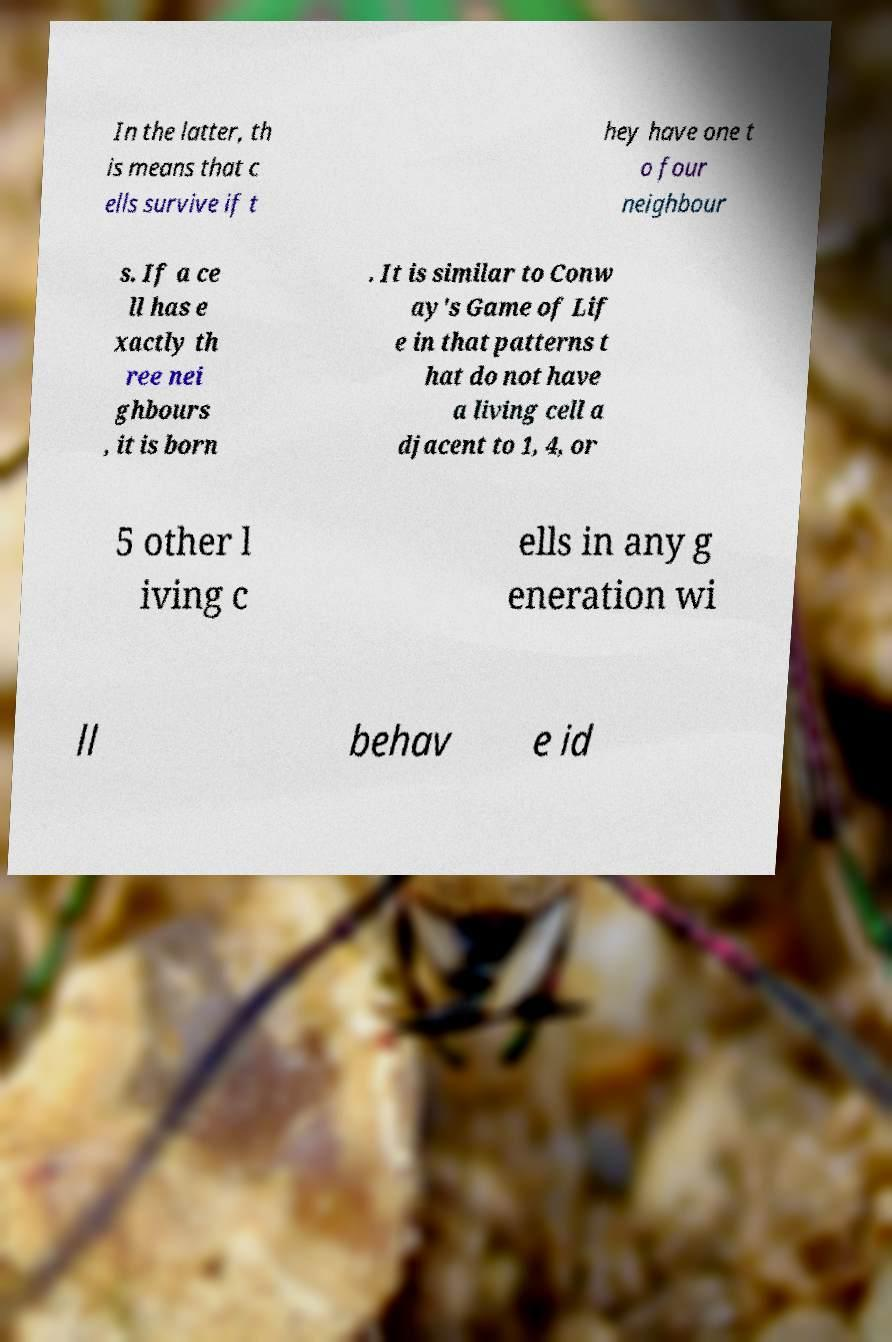Please identify and transcribe the text found in this image. In the latter, th is means that c ells survive if t hey have one t o four neighbour s. If a ce ll has e xactly th ree nei ghbours , it is born . It is similar to Conw ay's Game of Lif e in that patterns t hat do not have a living cell a djacent to 1, 4, or 5 other l iving c ells in any g eneration wi ll behav e id 